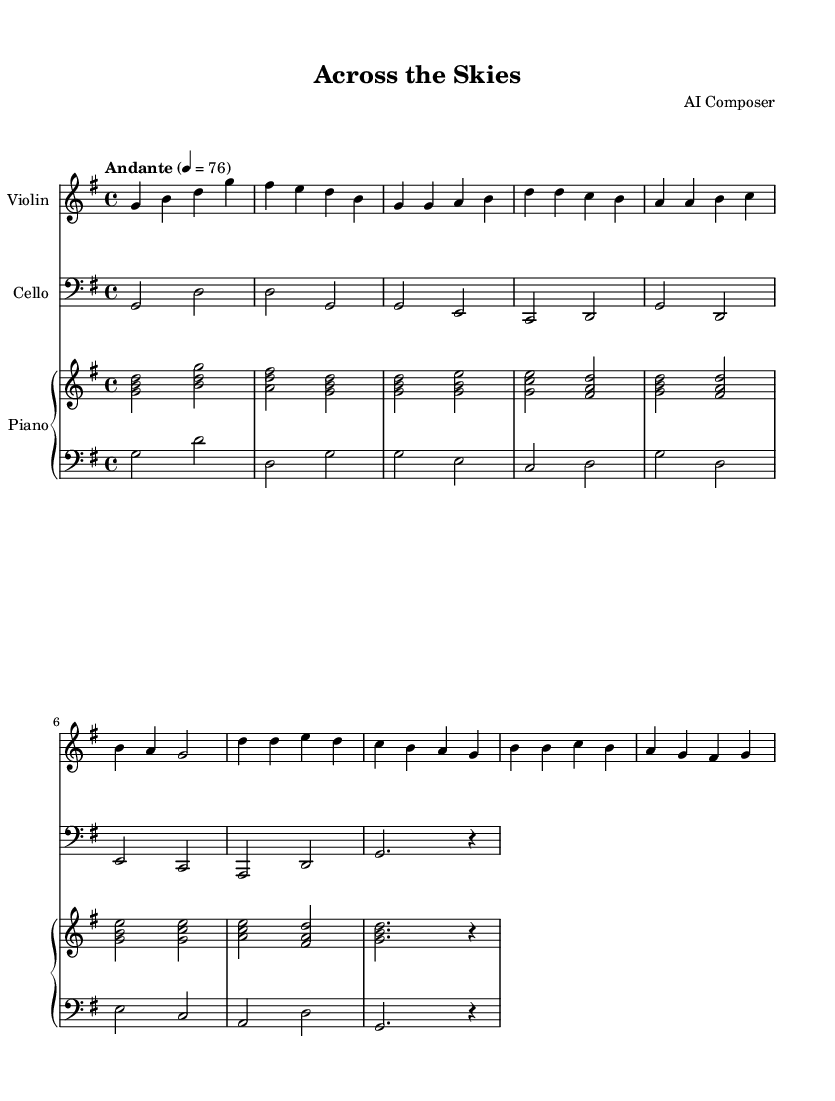What is the time signature of this music? The time signature is indicated at the beginning of the sheet music, where it shows 4/4, meaning there are four beats per measure and the quarter note receives one beat.
Answer: 4/4 What is the key signature of this music? The key signature is marked at the beginning, showing one sharp indicated by the "F#" in the G major scale, which comprises G, A, B, C, D, E, and F#.
Answer: G major What is the tempo of this piece? The tempo is indicated at the beginning of the music, stating "Andante" with a metronome marking of 76, which means it should be performed at a moderately slow pace.
Answer: Andante, 76 How many measures are in the intro section? The intro section consists of two measures, which can be counted by looking at the first part of the sheet music before the first verse starts. Each measure is separated by vertical lines.
Answer: 2 What instruments are included in this arrangement? The arrangement includes four instruments, which can be identified by looking at the staff headers: Violin, Cello, Right hand of Piano, and Left hand of Piano.
Answer: Violin, Cello, Piano In which section does the melody first change within the music? The melody first changes at the beginning of the chorus, where the notes have a different pattern compared to the verse section. This can be identified visually as the pitches and rhythms alter.
Answer: Chorus How many sharps are present in the key signature? The key signature shows one sharp (F#), indicated at the beginning of the sheet music. Counting the sharps present provides the answer.
Answer: 1 